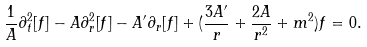Convert formula to latex. <formula><loc_0><loc_0><loc_500><loc_500>\frac { 1 } { A } \partial _ { t } ^ { 2 } [ f ] - A \partial _ { r } ^ { 2 } [ f ] - A ^ { \prime } \partial _ { r } [ f ] + ( \frac { 3 A ^ { \prime } } { r } + \frac { 2 A } { r ^ { 2 } } + m ^ { 2 } ) f = 0 .</formula> 